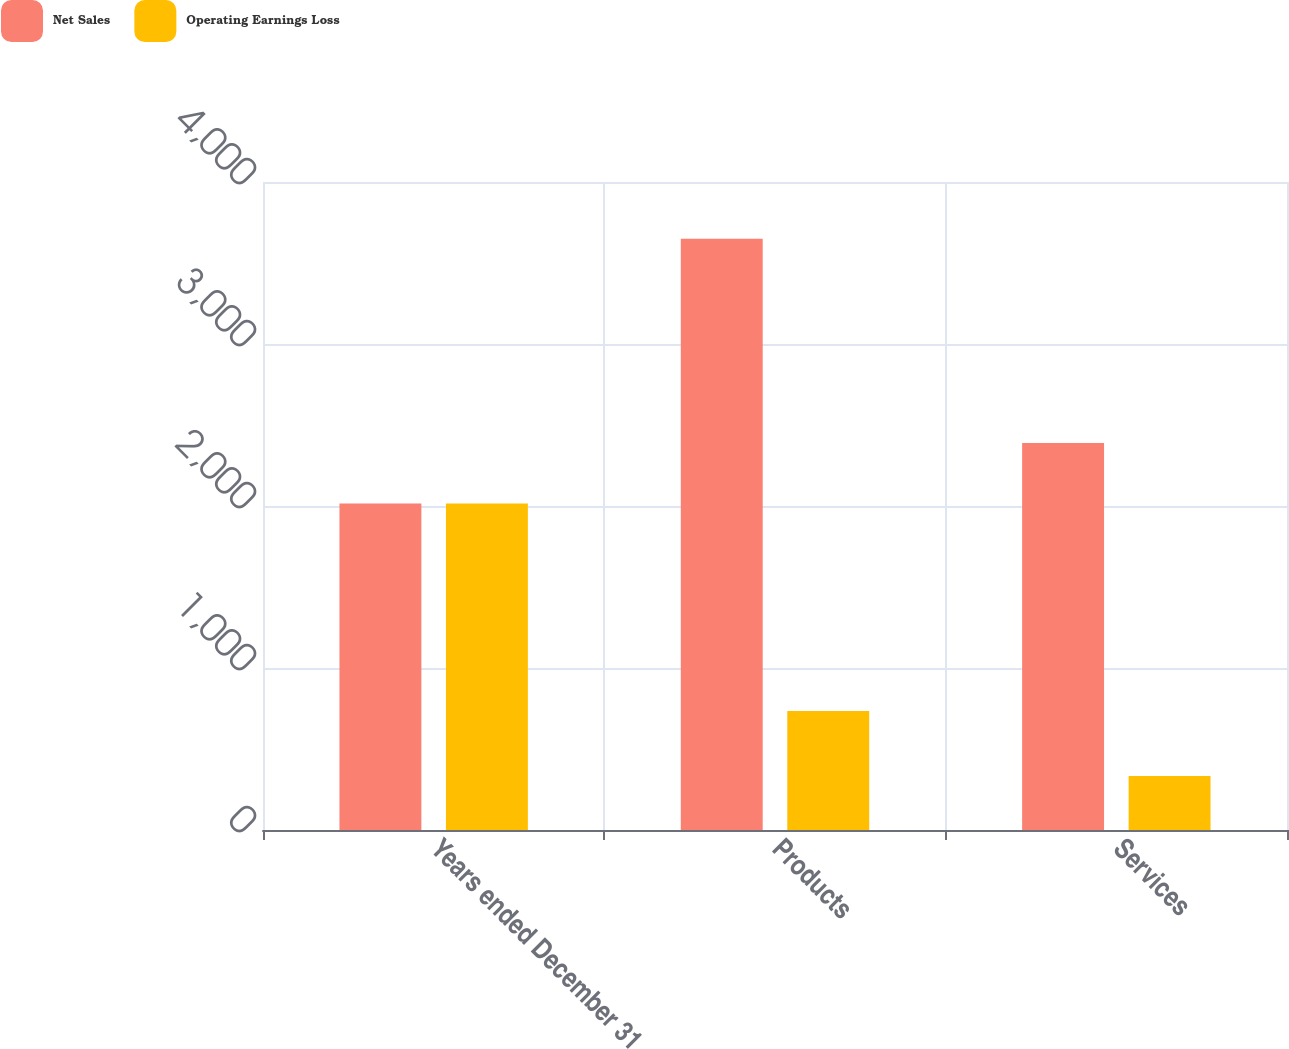Convert chart. <chart><loc_0><loc_0><loc_500><loc_500><stacked_bar_chart><ecel><fcel>Years ended December 31<fcel>Products<fcel>Services<nl><fcel>Net Sales<fcel>2016<fcel>3649<fcel>2389<nl><fcel>Operating Earnings Loss<fcel>2016<fcel>734<fcel>333<nl></chart> 